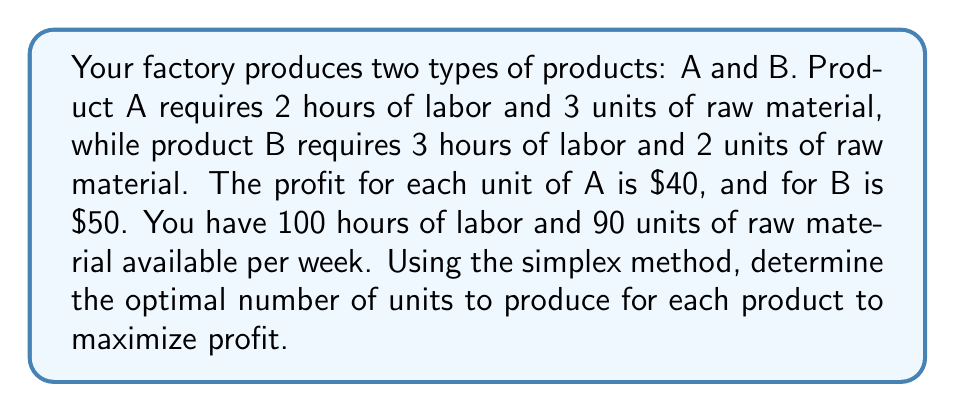Can you answer this question? Let's solve this step-by-step using the simplex method:

1) Define variables:
   Let $x$ be the number of units of product A
   Let $y$ be the number of units of product B

2) Formulate the objective function:
   Maximize $Z = 40x + 50y$

3) Identify constraints:
   Labor: $2x + 3y \leq 100$
   Raw material: $3x + 2y \leq 90$
   Non-negativity: $x \geq 0$, $y \geq 0$

4) Convert to standard form by adding slack variables:
   $2x + 3y + s_1 = 100$
   $3x + 2y + s_2 = 90$
   $Z - 40x - 50y = 0$

5) Initial tableau:
   $$
   \begin{array}{c|cccccc}
    & x & y & s_1 & s_2 & \text{RHS} \\
   \hline
   s_1 & 2 & 3 & 1 & 0 & 100 \\
   s_2 & 3 & 2 & 0 & 1 & 90 \\
   Z & -40 & -50 & 0 & 0 & 0
   \end{array}
   $$

6) Identify entering variable (most negative in Z row): $y$

7) Identify leaving variable (smallest ratio of RHS to coefficient):
   $s_1: 100/3 = 33.33$
   $s_2: 90/2 = 45$
   $s_1$ leaves

8) Perform row operations to get new tableau:
   $$
   \begin{array}{c|cccccc}
    & x & y & s_1 & s_2 & \text{RHS} \\
   \hline
   y & 2/3 & 1 & 1/3 & 0 & 33.33 \\
   s_2 & 5/3 & 0 & -2/3 & 1 & 23.33 \\
   Z & -6.67 & 0 & 16.67 & 0 & 1666.67
   \end{array}
   $$

9) Repeat steps 6-8:
   Entering variable: $x$
   Leaving variable: $s_2$

10) Final tableau:
    $$
    \begin{array}{c|cccccc}
     & x & y & s_1 & s_2 & \text{RHS} \\
    \hline
    y & 0 & 1 & 0.6 & -0.4 & 26 \\
    x & 1 & 0 & -0.4 & 0.6 & 14 \\
    Z & 0 & 0 & 10 & 4 & 1760
    \end{array}
    $$

11) Read solution: $x = 14$, $y = 26$, maximum profit $Z = 1760$
Answer: Produce 14 units of A and 26 units of B for maximum profit of $1760. 